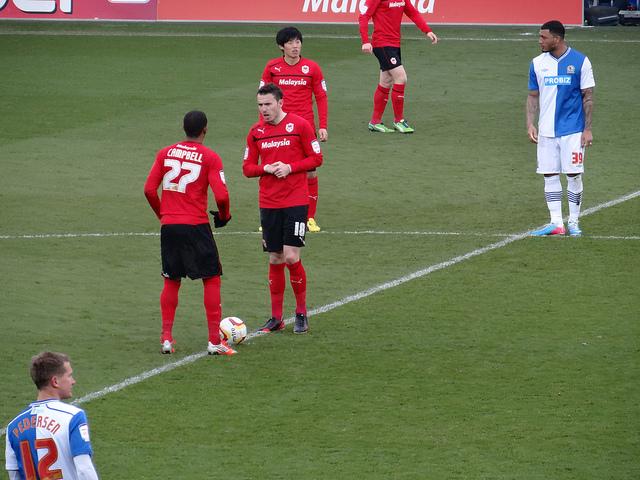What color are his shorts?
Answer briefly. Black. Is this baseball or football?
Write a very short answer. Football. What color is number 4's shirt?
Keep it brief. Red. What game are they playing?
Write a very short answer. Soccer. Are these people professional athletes?
Concise answer only. Yes. What is this person doing?
Be succinct. Playing soccer. Is the soccer ball lying on a field stripe?
Short answer required. Yes. What team is shown?
Write a very short answer. Malaysia. What sport are the men playing on the field?
Keep it brief. Soccer. 